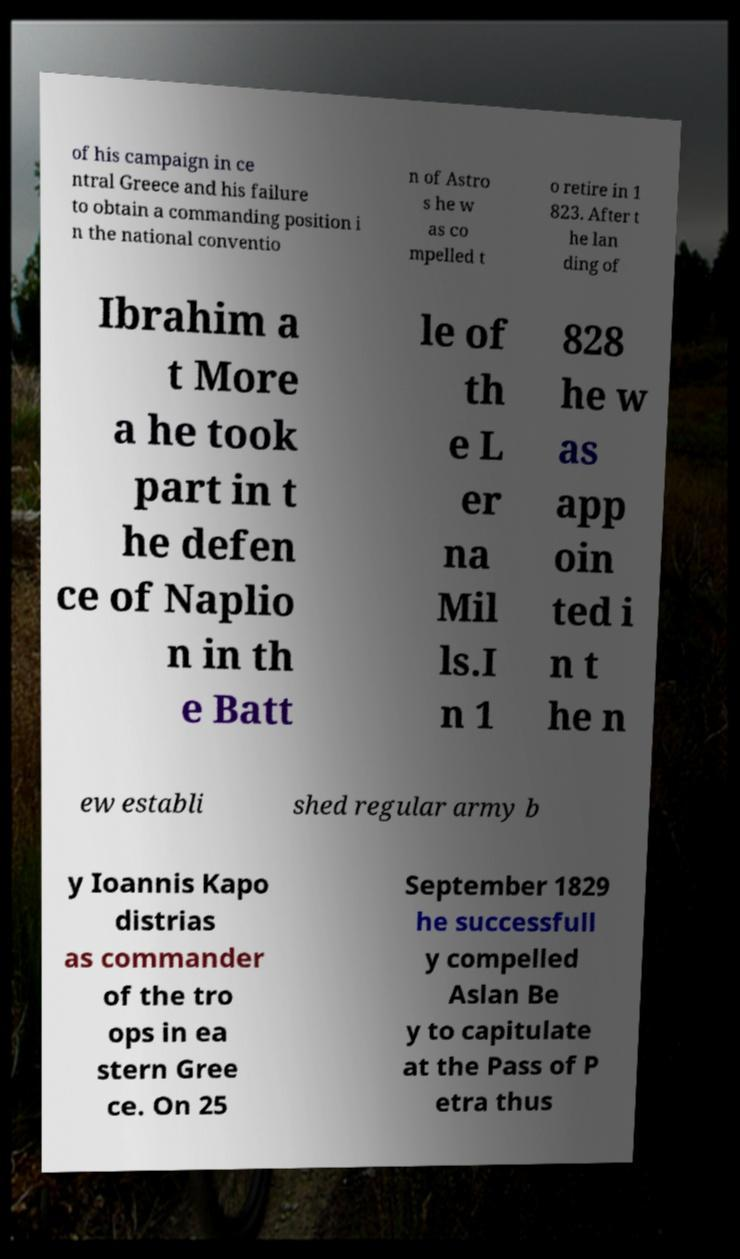Can you accurately transcribe the text from the provided image for me? of his campaign in ce ntral Greece and his failure to obtain a commanding position i n the national conventio n of Astro s he w as co mpelled t o retire in 1 823. After t he lan ding of Ibrahim a t More a he took part in t he defen ce of Naplio n in th e Batt le of th e L er na Mil ls.I n 1 828 he w as app oin ted i n t he n ew establi shed regular army b y Ioannis Kapo distrias as commander of the tro ops in ea stern Gree ce. On 25 September 1829 he successfull y compelled Aslan Be y to capitulate at the Pass of P etra thus 